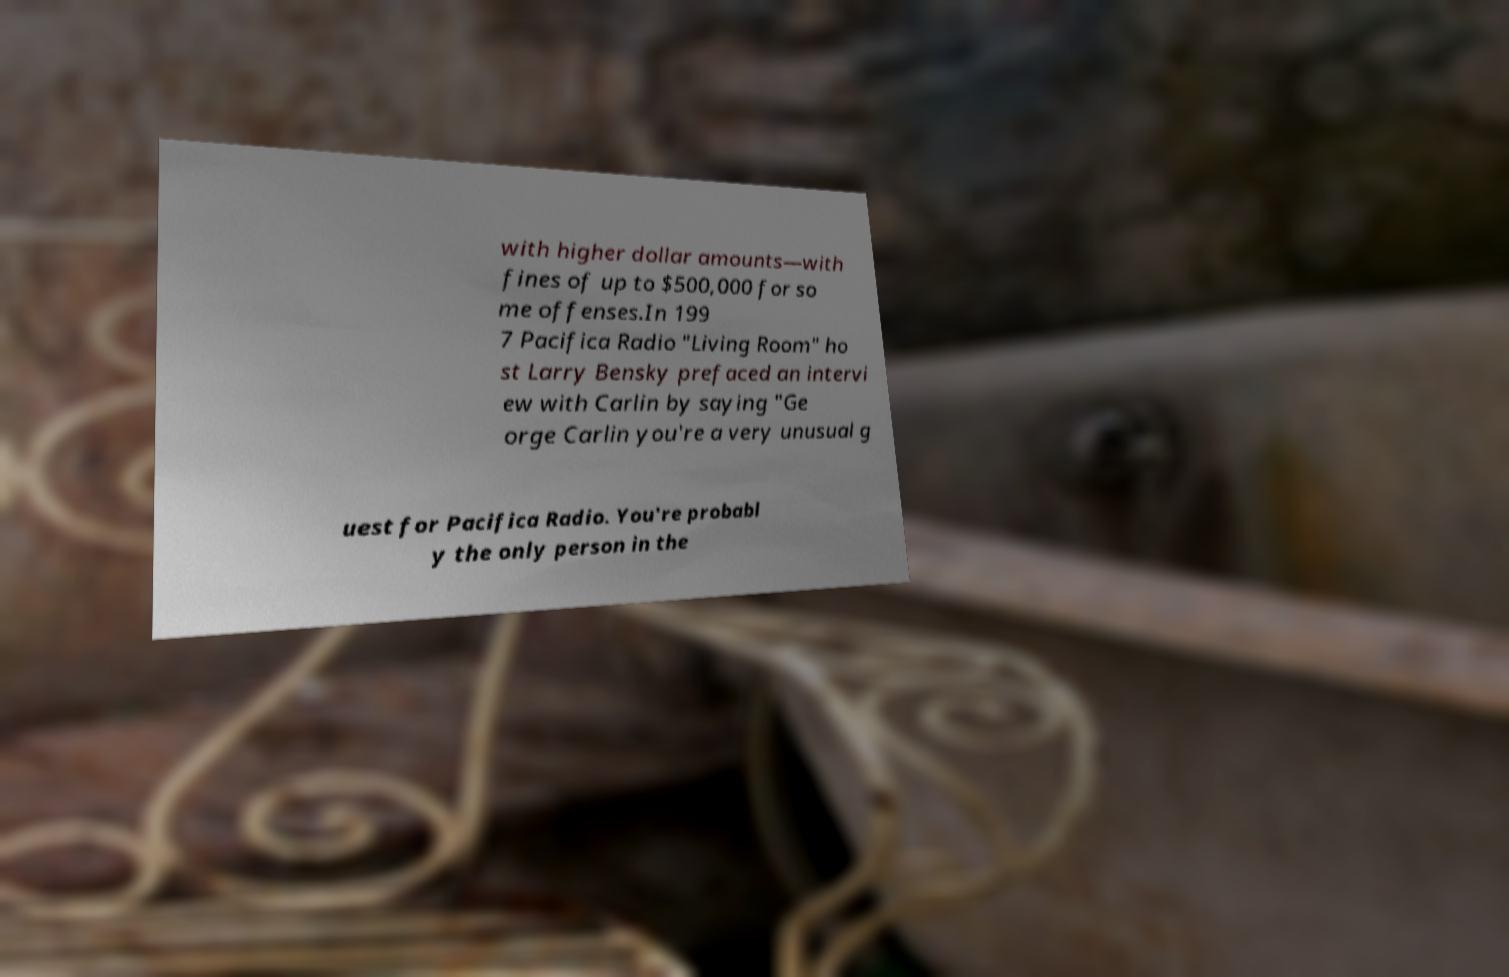Please read and relay the text visible in this image. What does it say? with higher dollar amounts—with fines of up to $500,000 for so me offenses.In 199 7 Pacifica Radio "Living Room" ho st Larry Bensky prefaced an intervi ew with Carlin by saying "Ge orge Carlin you're a very unusual g uest for Pacifica Radio. You're probabl y the only person in the 